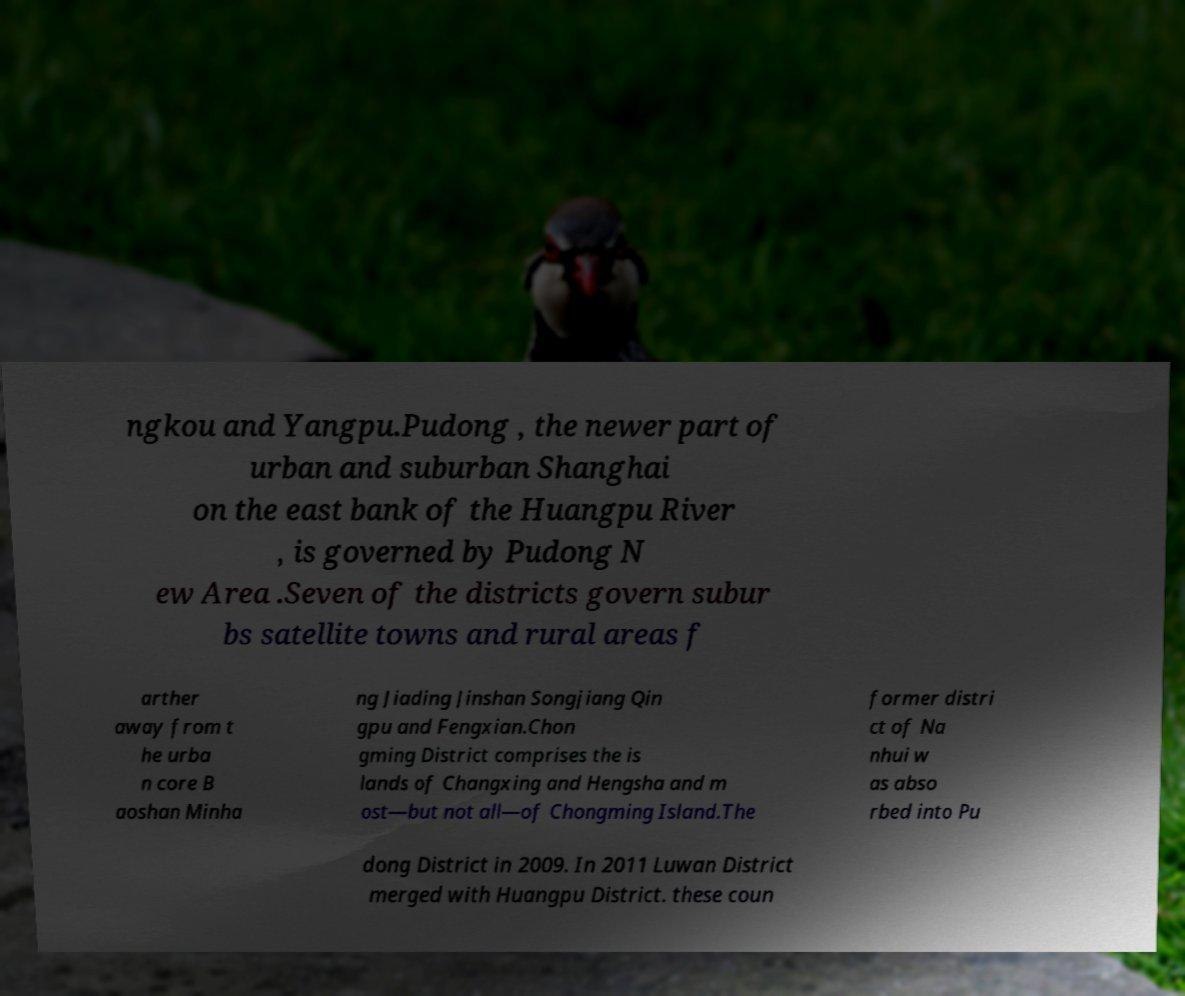Please read and relay the text visible in this image. What does it say? ngkou and Yangpu.Pudong , the newer part of urban and suburban Shanghai on the east bank of the Huangpu River , is governed by Pudong N ew Area .Seven of the districts govern subur bs satellite towns and rural areas f arther away from t he urba n core B aoshan Minha ng Jiading Jinshan Songjiang Qin gpu and Fengxian.Chon gming District comprises the is lands of Changxing and Hengsha and m ost—but not all—of Chongming Island.The former distri ct of Na nhui w as abso rbed into Pu dong District in 2009. In 2011 Luwan District merged with Huangpu District. these coun 